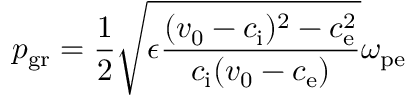Convert formula to latex. <formula><loc_0><loc_0><loc_500><loc_500>p _ { g r } = \frac { 1 } { 2 } \sqrt { \epsilon \frac { ( v _ { 0 } - c _ { i } ) ^ { 2 } - c _ { e } ^ { 2 } } { c _ { i } ( v _ { 0 } - c _ { e } ) } } \omega _ { p e }</formula> 